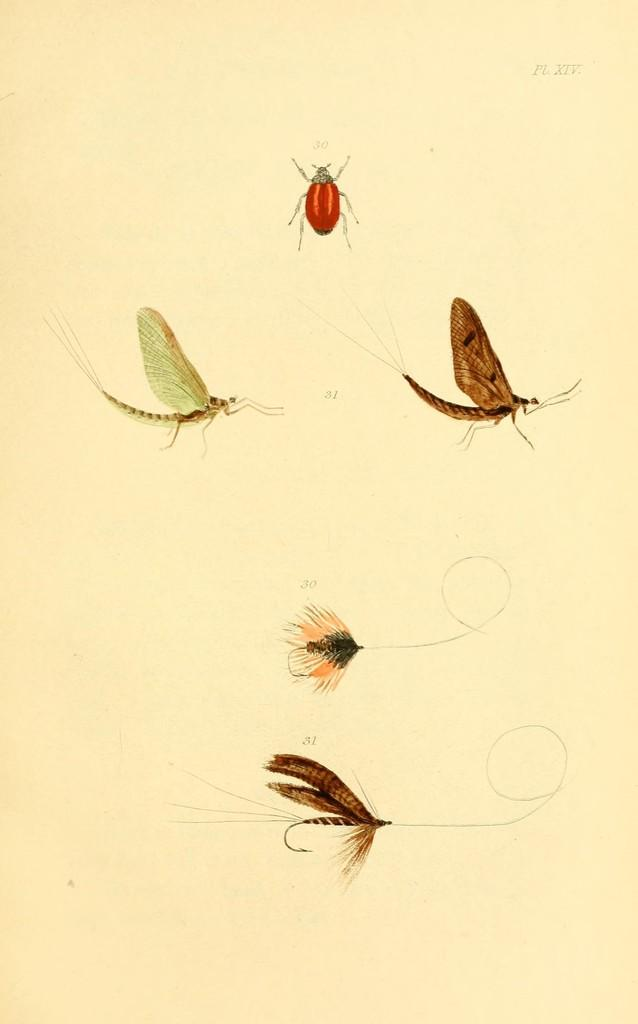What type of artwork is the image? The image is a painting. What is the subject matter of the painting? The painting depicts different insects. What color is the background of the painting? The background of the painting is cream. Where is the text located in the painting? The text is at the top right of the painting. What type of finger can be seen holding the painting? There is no finger present in the image; it is a painting of insects on a cream background with text at the top right. 